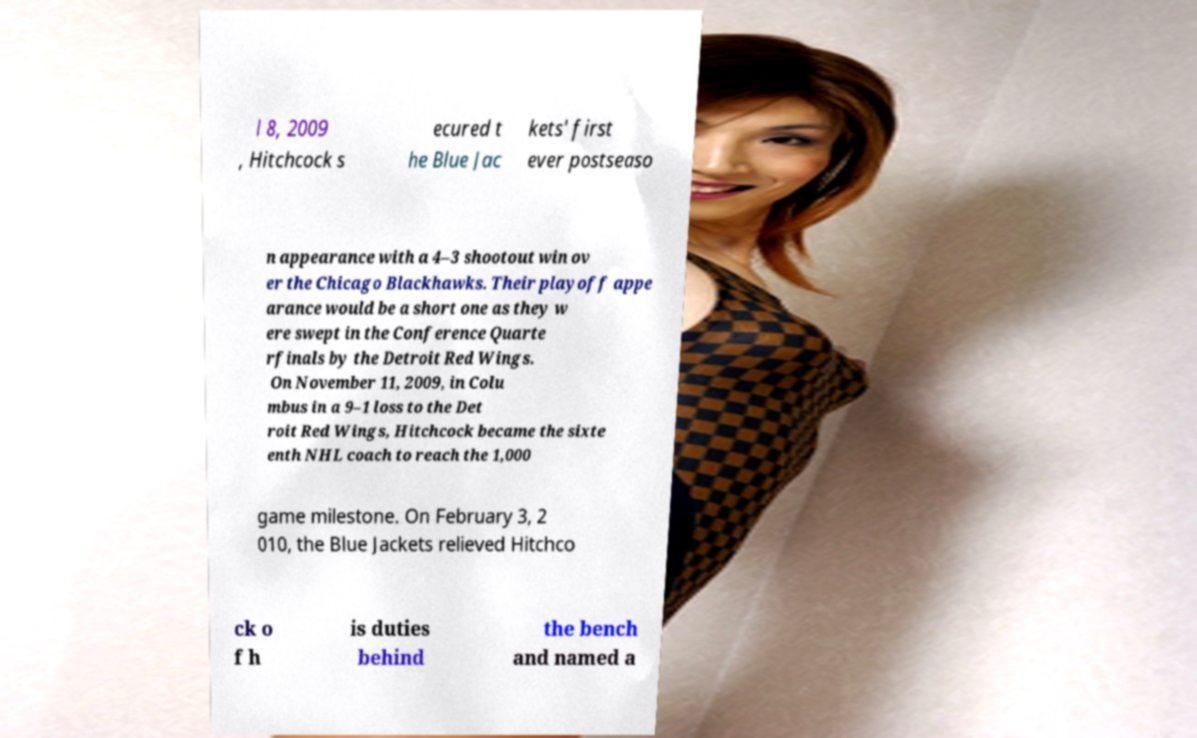Could you assist in decoding the text presented in this image and type it out clearly? l 8, 2009 , Hitchcock s ecured t he Blue Jac kets' first ever postseaso n appearance with a 4–3 shootout win ov er the Chicago Blackhawks. Their playoff appe arance would be a short one as they w ere swept in the Conference Quarte rfinals by the Detroit Red Wings. On November 11, 2009, in Colu mbus in a 9–1 loss to the Det roit Red Wings, Hitchcock became the sixte enth NHL coach to reach the 1,000 game milestone. On February 3, 2 010, the Blue Jackets relieved Hitchco ck o f h is duties behind the bench and named a 